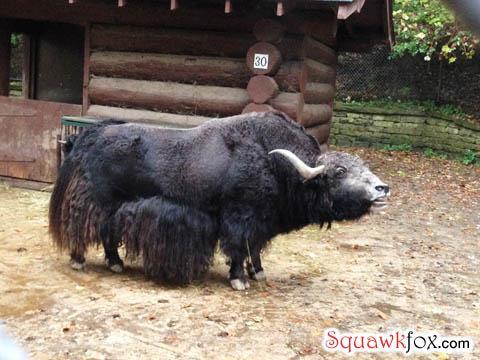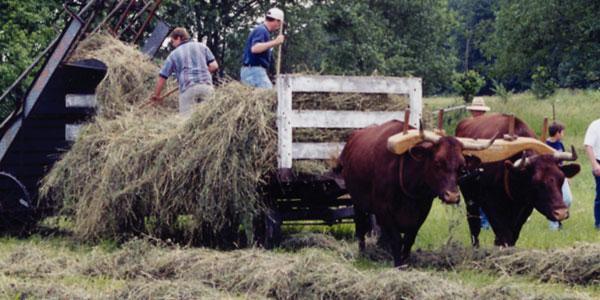The first image is the image on the left, the second image is the image on the right. For the images shown, is this caption "One man steering a plow is behind two oxen pulling the plow." true? Answer yes or no. No. The first image is the image on the left, the second image is the image on the right. Evaluate the accuracy of this statement regarding the images: "The left image shows a man walking behind a pair of cattle attached to a farming implement .". Is it true? Answer yes or no. No. 